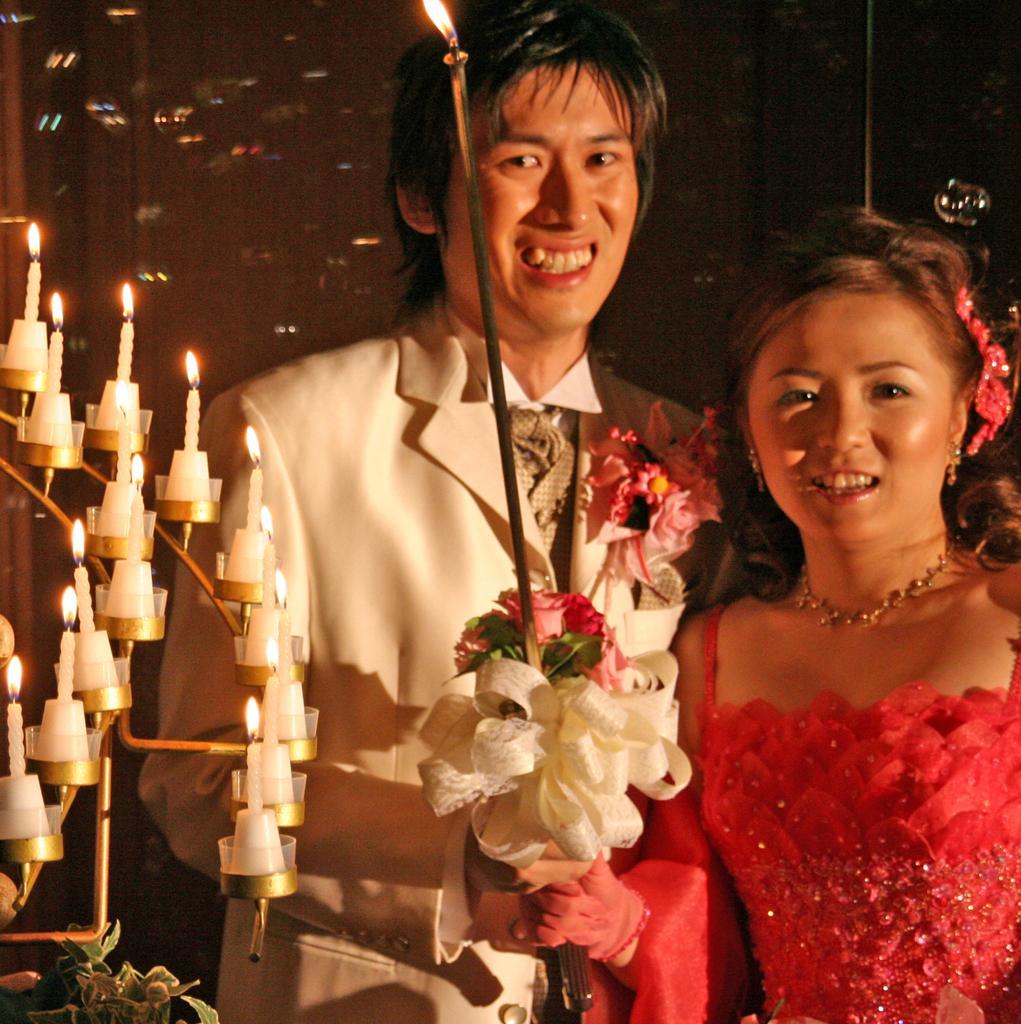Please provide a concise description of this image. In the picture I can see a person wearing white color blazer and a woman wearing red color dress are holding flower bouquet in their hands and smiling. Here I can see candles are kept on the stand which is on the left side of the image and the background of the image is dark. 